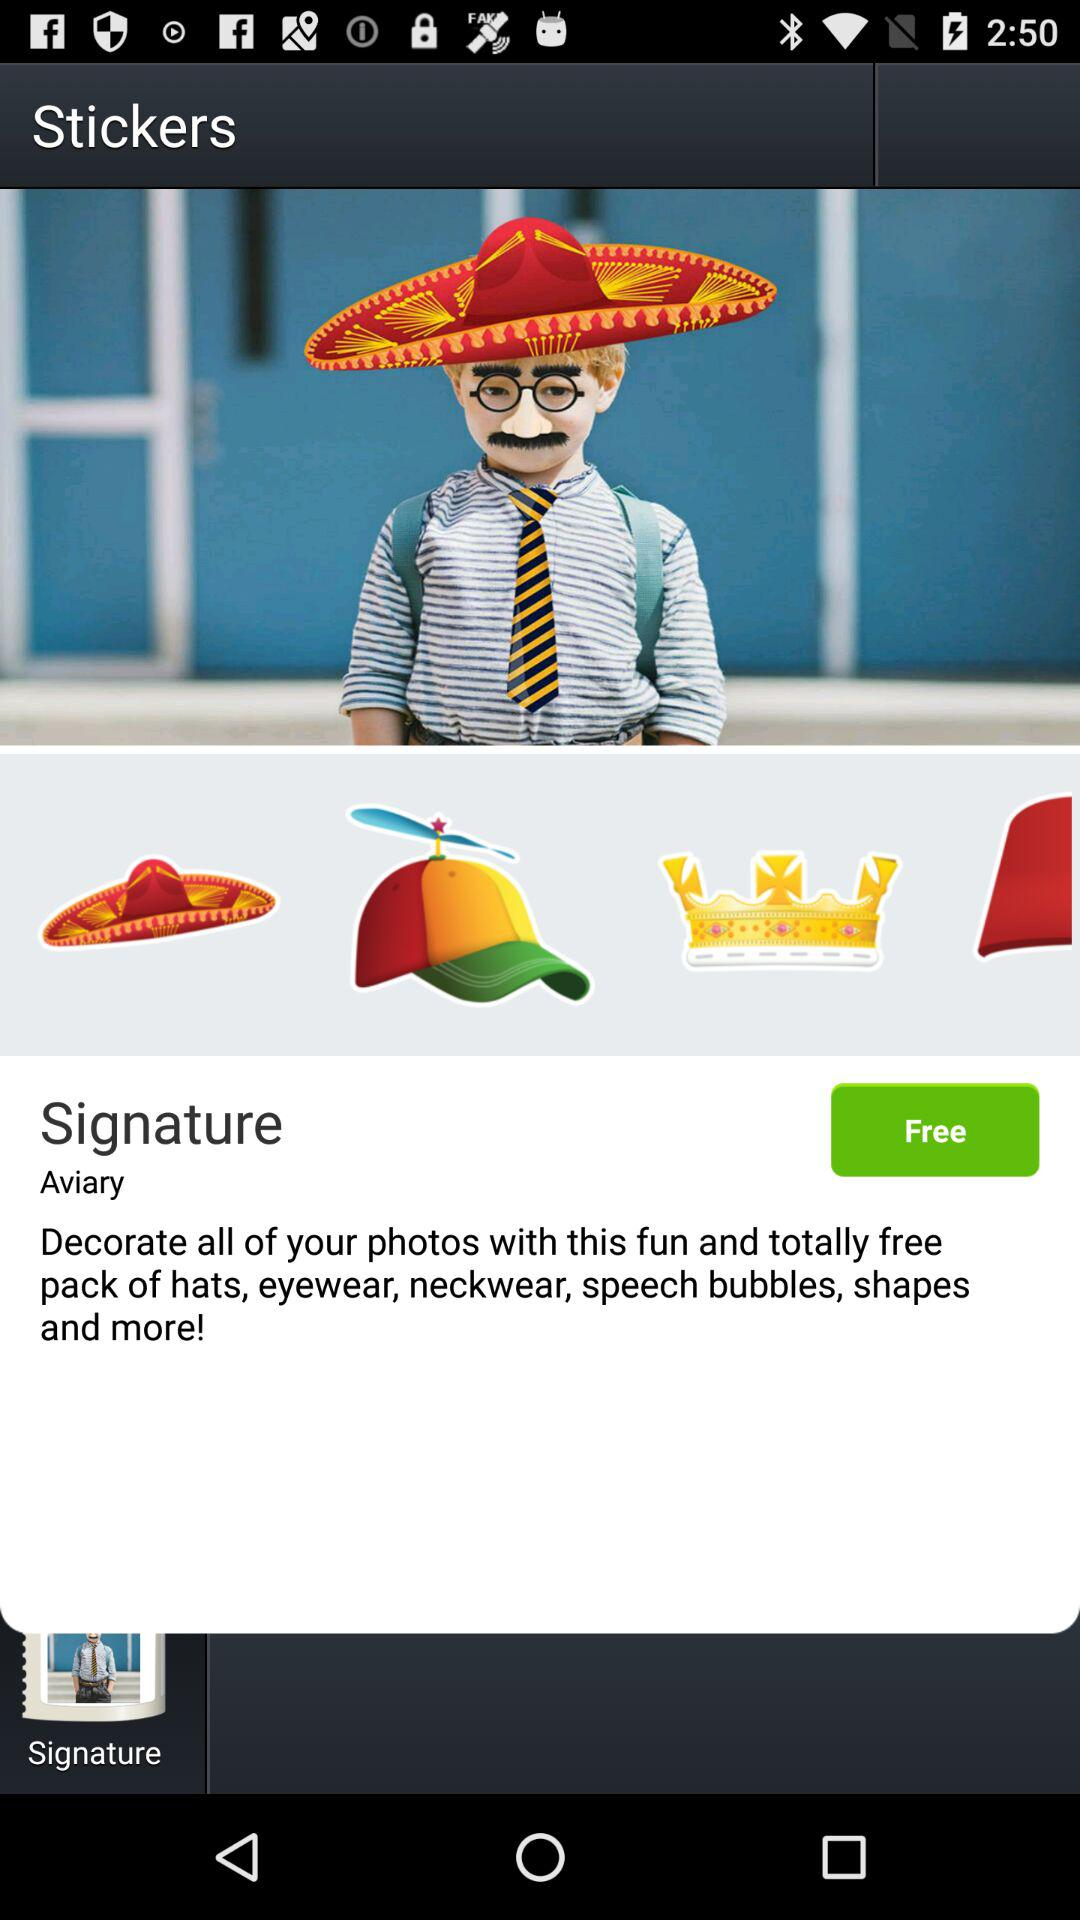How many stickers are there in the pack?
Answer the question using a single word or phrase. 4 